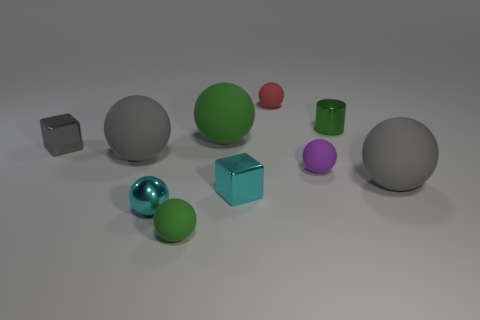Subtract all tiny green balls. How many balls are left? 6 Subtract all cyan spheres. How many spheres are left? 6 Subtract 3 spheres. How many spheres are left? 4 Subtract all brown spheres. Subtract all blue cylinders. How many spheres are left? 7 Subtract all cylinders. How many objects are left? 9 Add 3 big purple rubber cubes. How many big purple rubber cubes exist? 3 Subtract 0 purple cylinders. How many objects are left? 10 Subtract all gray metal cubes. Subtract all large green balls. How many objects are left? 8 Add 6 green metallic cylinders. How many green metallic cylinders are left? 7 